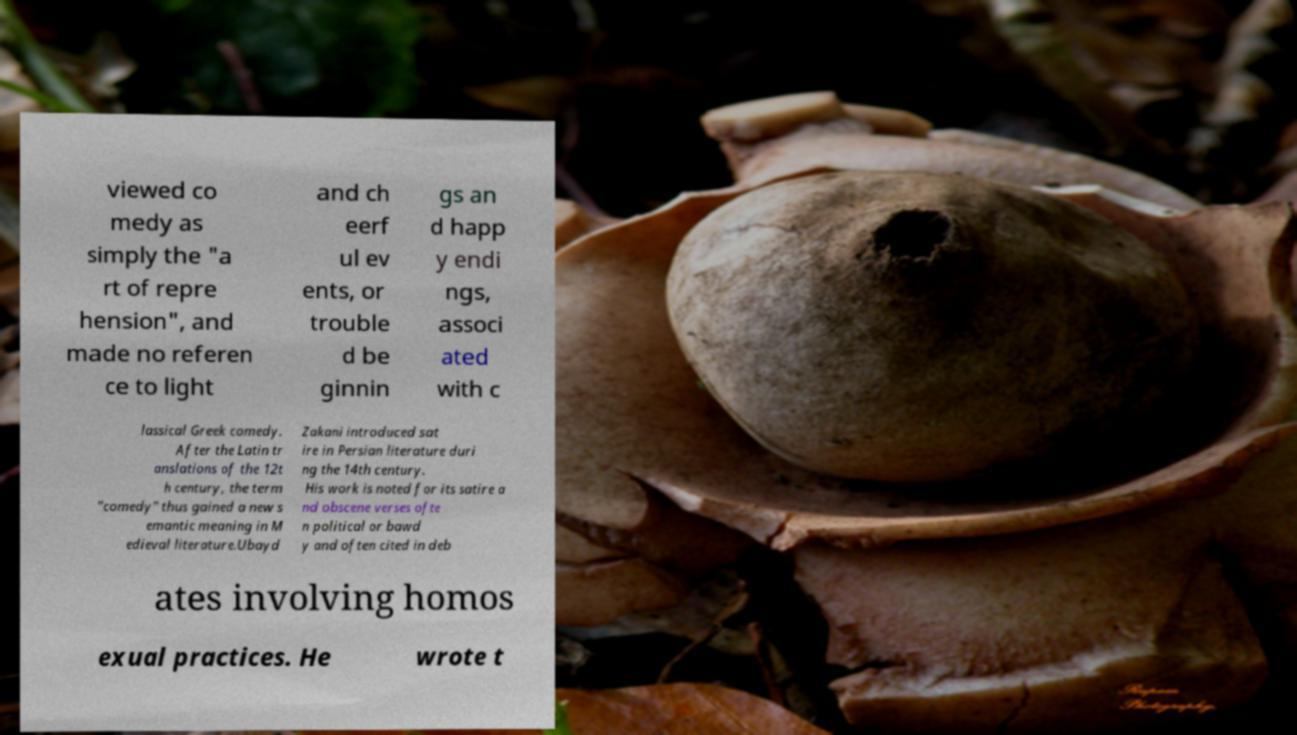There's text embedded in this image that I need extracted. Can you transcribe it verbatim? viewed co medy as simply the "a rt of repre hension", and made no referen ce to light and ch eerf ul ev ents, or trouble d be ginnin gs an d happ y endi ngs, associ ated with c lassical Greek comedy. After the Latin tr anslations of the 12t h century, the term "comedy" thus gained a new s emantic meaning in M edieval literature.Ubayd Zakani introduced sat ire in Persian literature duri ng the 14th century. His work is noted for its satire a nd obscene verses ofte n political or bawd y and often cited in deb ates involving homos exual practices. He wrote t 